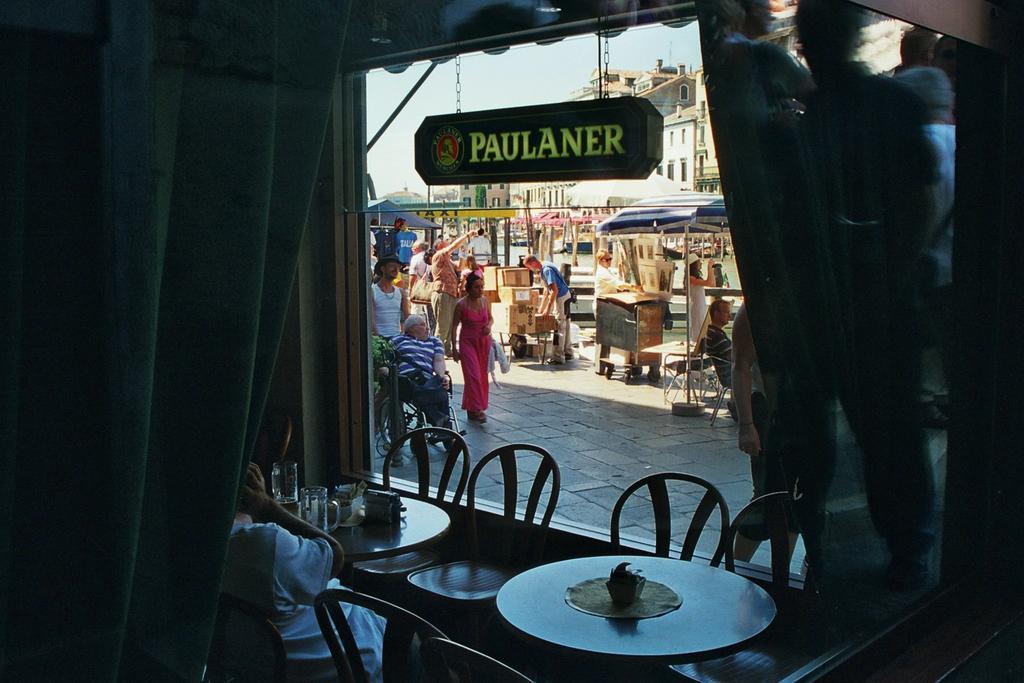Can you describe this image briefly? It is an inside view of the shop. Here we can see tables, chairs. Few items are placed on it. At the bottom, we can see a person is hitting on the chair. Here there is a glass, hoarding. Here we can see the outside view. Few people, carton boxes, some objects, umbrellas, buildings, platform and sky we can see. 